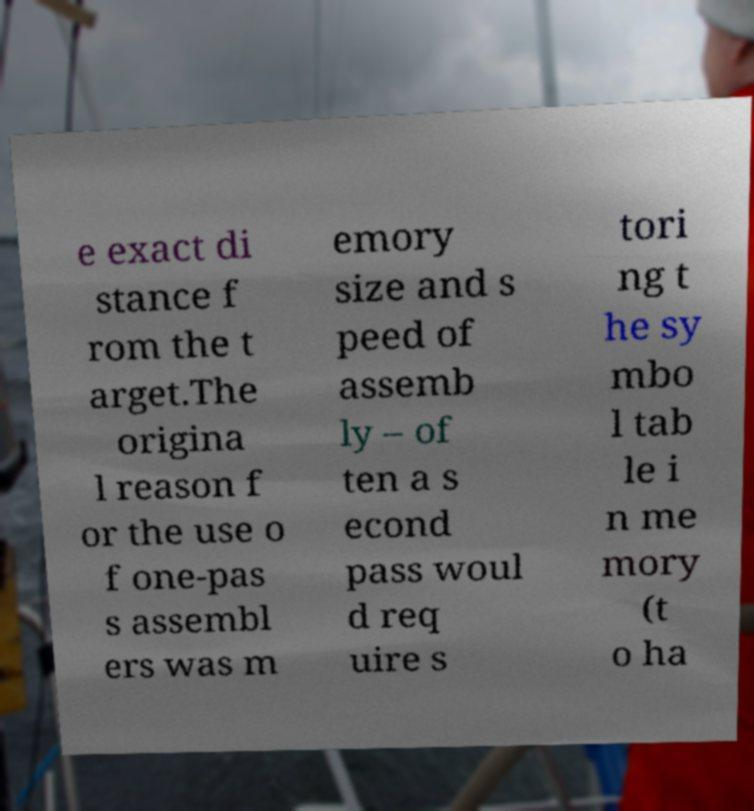Could you extract and type out the text from this image? e exact di stance f rom the t arget.The origina l reason f or the use o f one-pas s assembl ers was m emory size and s peed of assemb ly – of ten a s econd pass woul d req uire s tori ng t he sy mbo l tab le i n me mory (t o ha 